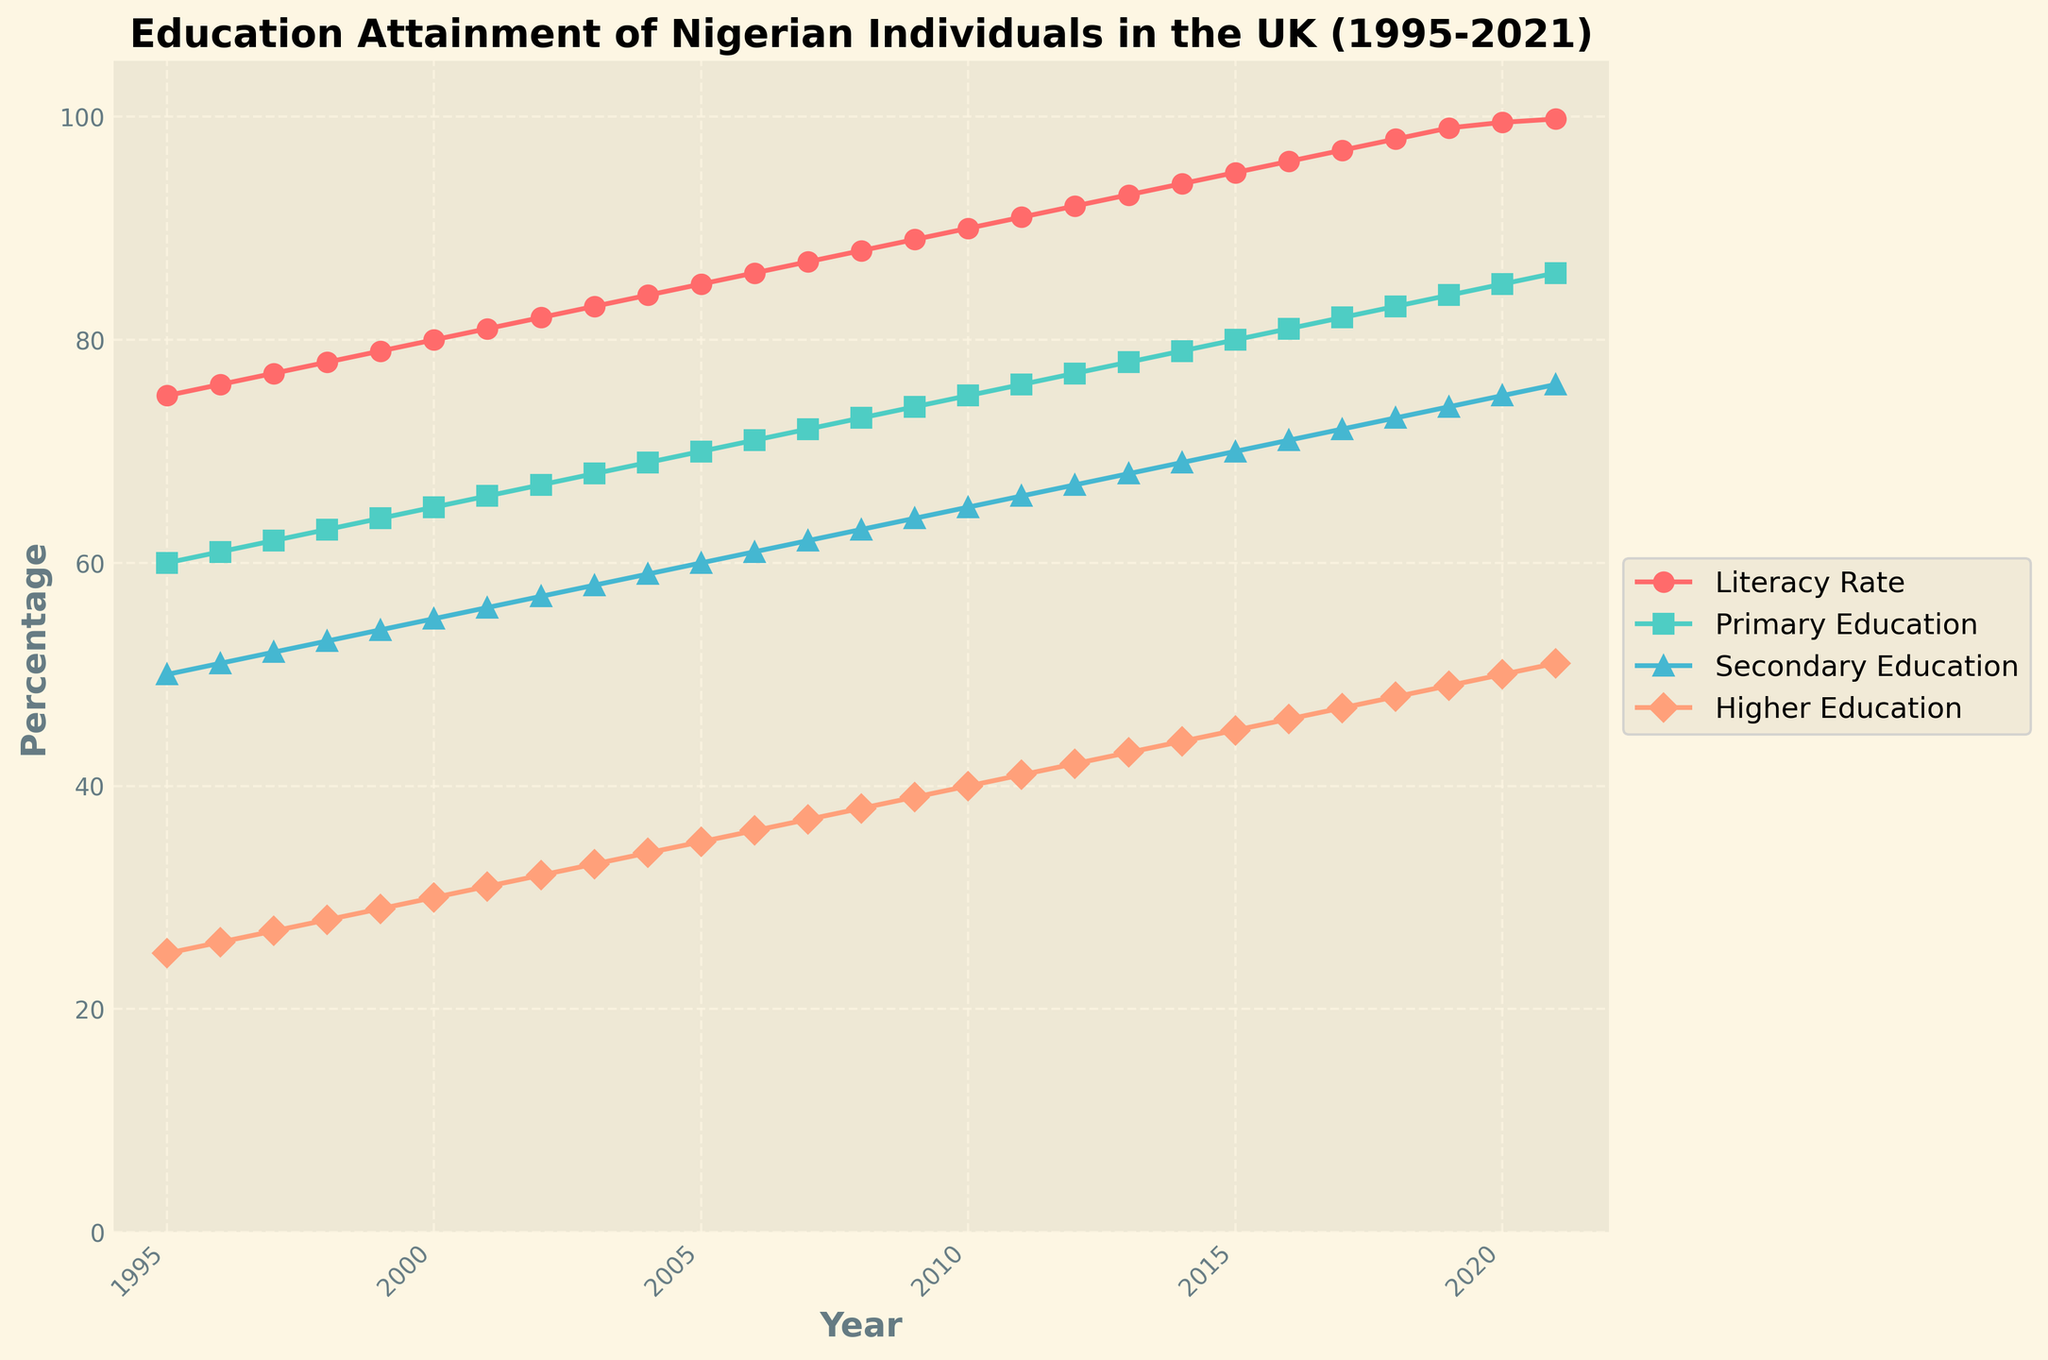When did the Literacy Rate of Nigerian individuals in the UK reach 90%? First, find the literacy rate line in the plot, then locate the point where the literacy rate is 90% and check the corresponding year on the x-axis.
Answer: 2010 How many years did it take for the Higher Education Completion Percentage to increase from 25% to 50%? Identify the years where the higher education completion percentages were 25% and 50%. Then, subtract the earlier year from the later year.
Answer: 25 years Which education level shows the most significant increase from 1995 to 2021? Calculate the increase for each education level by subtracting their 1995 values from their 2021 values. Compare these increases. The higher education level shows the most significant increase.
Answer: Higher Education What was the approximate Primary Education Completion Percentage in 2005? Find the primary education completion percentage line in the plot and locate the point corresponding to the year 2005.
Answer: 70% At what year did the Literacy Rate surpass 95%? Trace the literacy rate line to find the year where it first goes above 95% and verify the value on the x-axis.
Answer: 2015 Which year did all education levels first simultaneously pass the 50% mark? Identify the year when the primary, secondary, and higher education completion percentages all are above 50% by tracing their respective lines on the plot.
Answer: 2001 What is the improvement in the Secondary Education Completion Percentage between 1995 and 2021? Subtract the secondary education completion percentage in 1995 from the percentage in 2021.
Answer: 26% Is there any year where the Literacy Rate remained constant? Examine the literacy rate line in the plot to see if there are any horizontal segments indicating no change from one year to the next.
Answer: No In which year did the Primary Education Completion Percentage exceed 75%? Identify the year when the primary education line first crosses the 75% mark and verify it with the x-axis.
Answer: 2010 